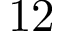Convert formula to latex. <formula><loc_0><loc_0><loc_500><loc_500>1 2</formula> 